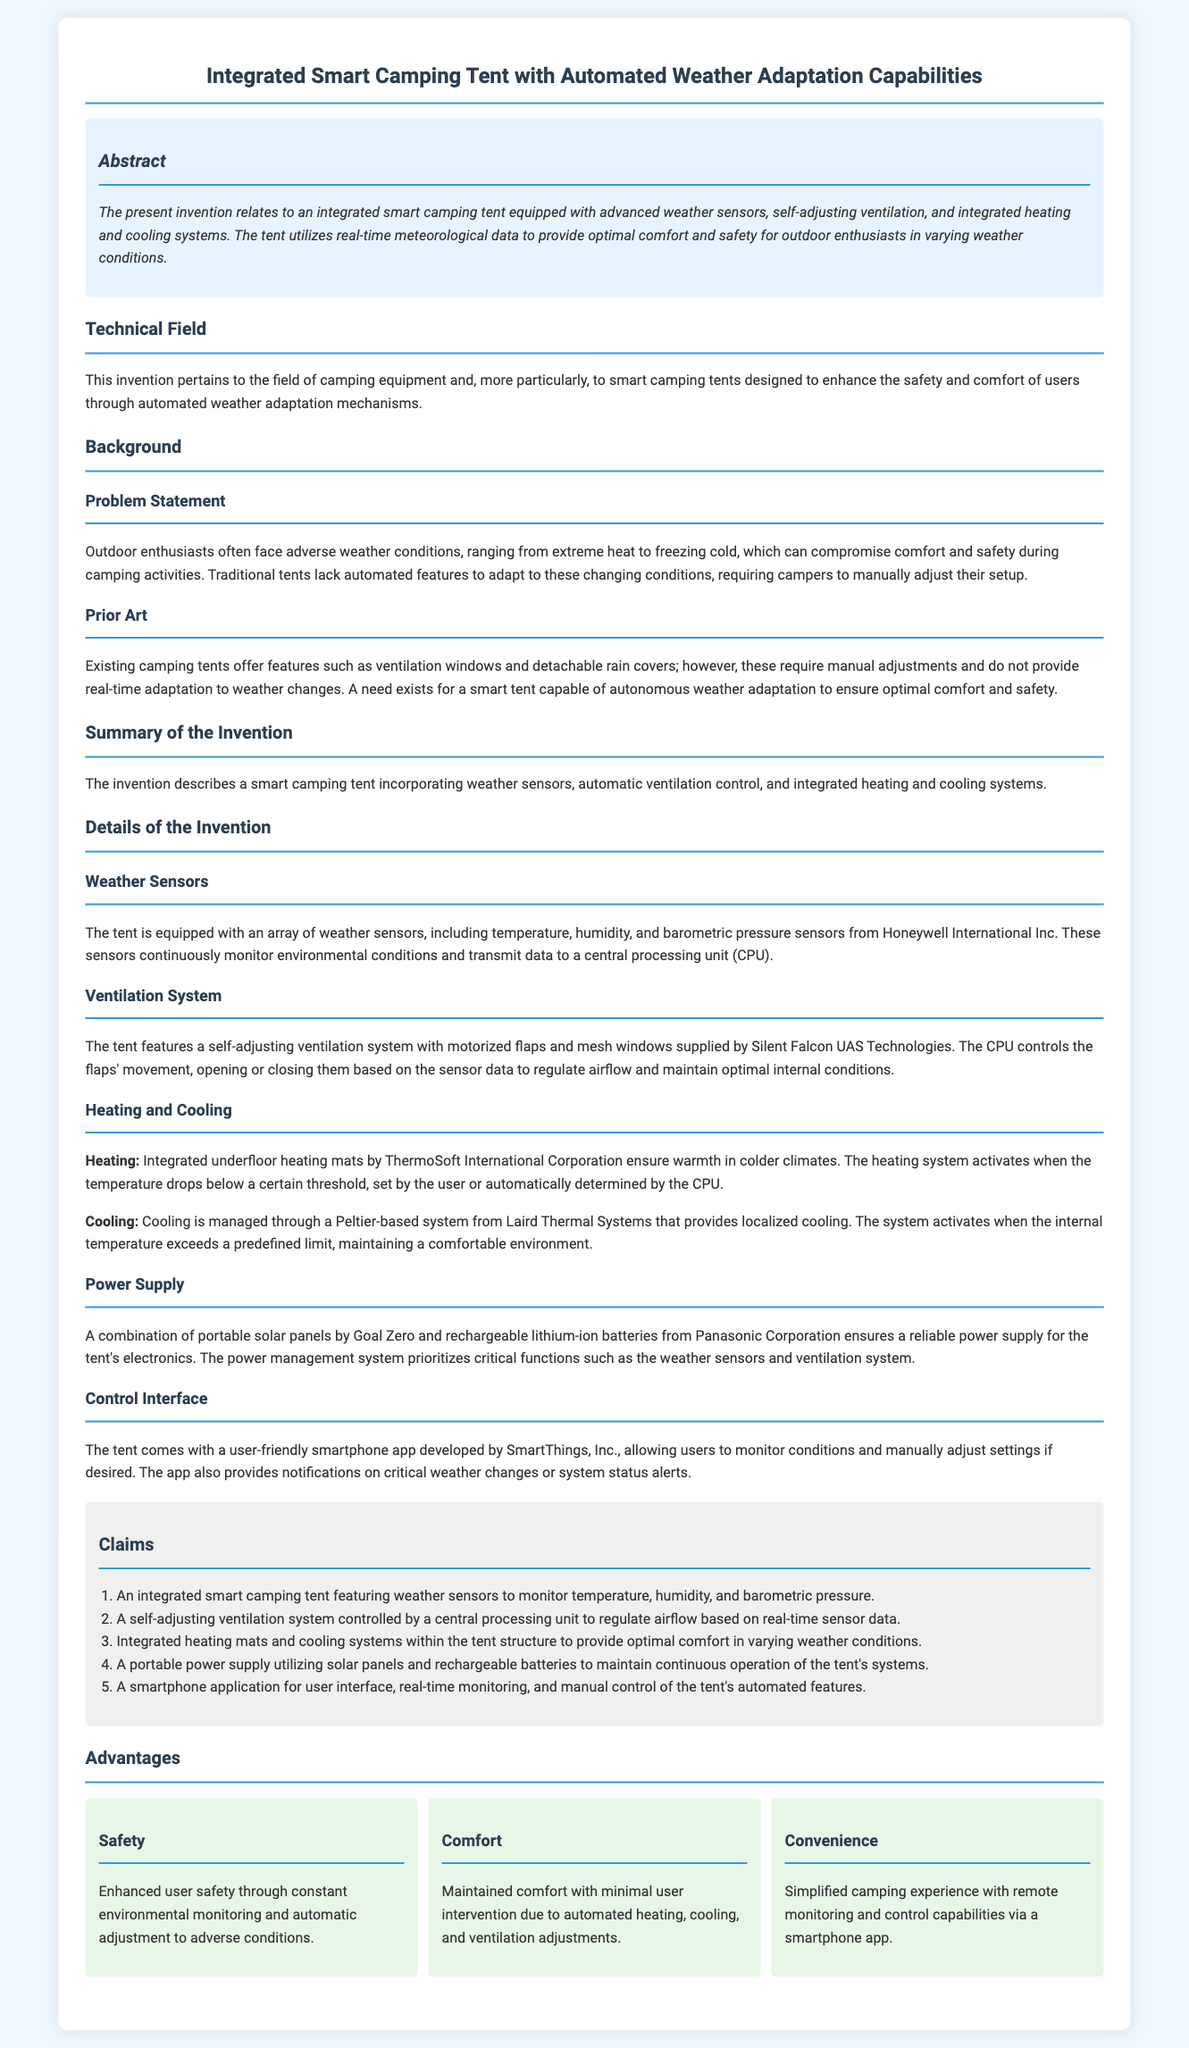what is the title of the patent application? The title of the patent application is given in the header section of the document.
Answer: Integrated Smart Camping Tent with Automated Weather Adaptation Capabilities what innovative features does the tent include? The innovative features of the tent are listed in the summary and details of the invention section.
Answer: Advanced weather sensors, self-adjusting ventilation, integrated heating and cooling systems who is the manufacturer of the weather sensors used in the tent? The manufacturer of the weather sensors is mentioned specifically in the details of the invention.
Answer: Honeywell International Inc what does the smartphone app developed by SmartThings, Inc. allow users to do? The functionalities of the app are outlined in the control interface section of the document.
Answer: Monitor conditions and manually adjust settings how many claims does the patent application contain? The number of claims is indicated in the claims section of the patent application.
Answer: Five what is one advantage of the integrated smart camping tent? Advantages are listed as individual points in the advantages section and highlight key benefits.
Answer: Enhanced user safety what type of power supply does the tent utilize? The type of power supply is summarized in the details section regarding the tent's systems.
Answer: Portable solar panels and rechargeable batteries what are the temperature control methods employed in the tent? Control methods related to temperature are specified in the heating and cooling sub-sections.
Answer: Heating mats and cooling systems what problems does the invention aim to solve? The problems targeted by the invention are detailed in the problem statement of the background section.
Answer: Adverse weather conditions affecting comfort and safety 